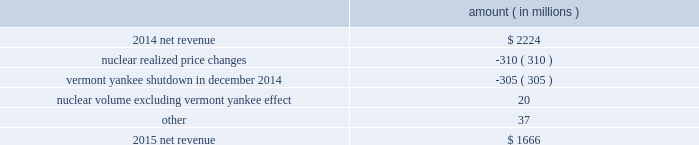Entergy corporation and subsidiaries management 2019s financial discussion and analysis the volume/weather variance is primarily due to an increase of 1402 gwh , or 1% ( 1 % ) , in billed electricity usage , including an increase in industrial usage and the effect of more favorable weather .
The increase in industrial sales was primarily due to expansion in the chemicals industry and the addition of new customers , partially offset by decreased demand primarily due to extended maintenance outages for existing chemicals customers .
The waterford 3 replacement steam generator provision is due to a regulatory charge of approximately $ 32 million recorded in 2015 related to the uncertainty associated with the resolution of the waterford 3 replacement steam generator project .
See note 2 to the financial statements for a discussion of the waterford 3 replacement steam generator prudence review proceeding .
The miso deferral variance is primarily due to the deferral in 2014 of non-fuel miso-related charges , as approved by the lpsc and the mpsc .
The deferral of non-fuel miso-related charges is partially offset in other operation and maintenance expenses .
See note 2 to the financial statements for further discussion of the recovery of non-fuel miso-related charges .
The louisiana business combination customer credits variance is due to a regulatory liability of $ 107 million recorded by entergy in october 2015 as a result of the entergy gulf states louisiana and entergy louisiana business combination .
Consistent with the terms of the stipulated settlement in the business combination proceeding , electric customers of entergy louisiana will realize customer credits associated with the business combination ; accordingly , in october 2015 , entergy recorded a regulatory liability of $ 107 million ( $ 66 million net-of-tax ) .
See note 2 to the financial statements for further discussion of the business combination and customer credits .
Entergy wholesale commodities following is an analysis of the change in net revenue comparing 2015 to 2014 .
Amount ( in millions ) .
As shown in the table above , net revenue for entergy wholesale commodities decreased by approximately $ 558 million in 2016 primarily due to : 2022 lower realized wholesale energy prices , primarily due to significantly higher northeast market power prices in 2014 , and lower capacity prices in 2015 ; and 2022 a decrease in net revenue as a result of vermont yankee ceasing power production in december 2014 .
The decrease was partially offset by higher volume in the entergy wholesale commodities nuclear fleet , excluding vermont yankee , resulting from fewer refueling outage days in 2015 as compared to 2014 , partially offset by more unplanned outage days in 2015 as compared to 2014. .
What is the net change in net revenue during 2015? 
Computations: (1666 - 2224)
Answer: -558.0. 